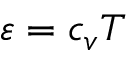Convert formula to latex. <formula><loc_0><loc_0><loc_500><loc_500>\varepsilon = c _ { v } T</formula> 